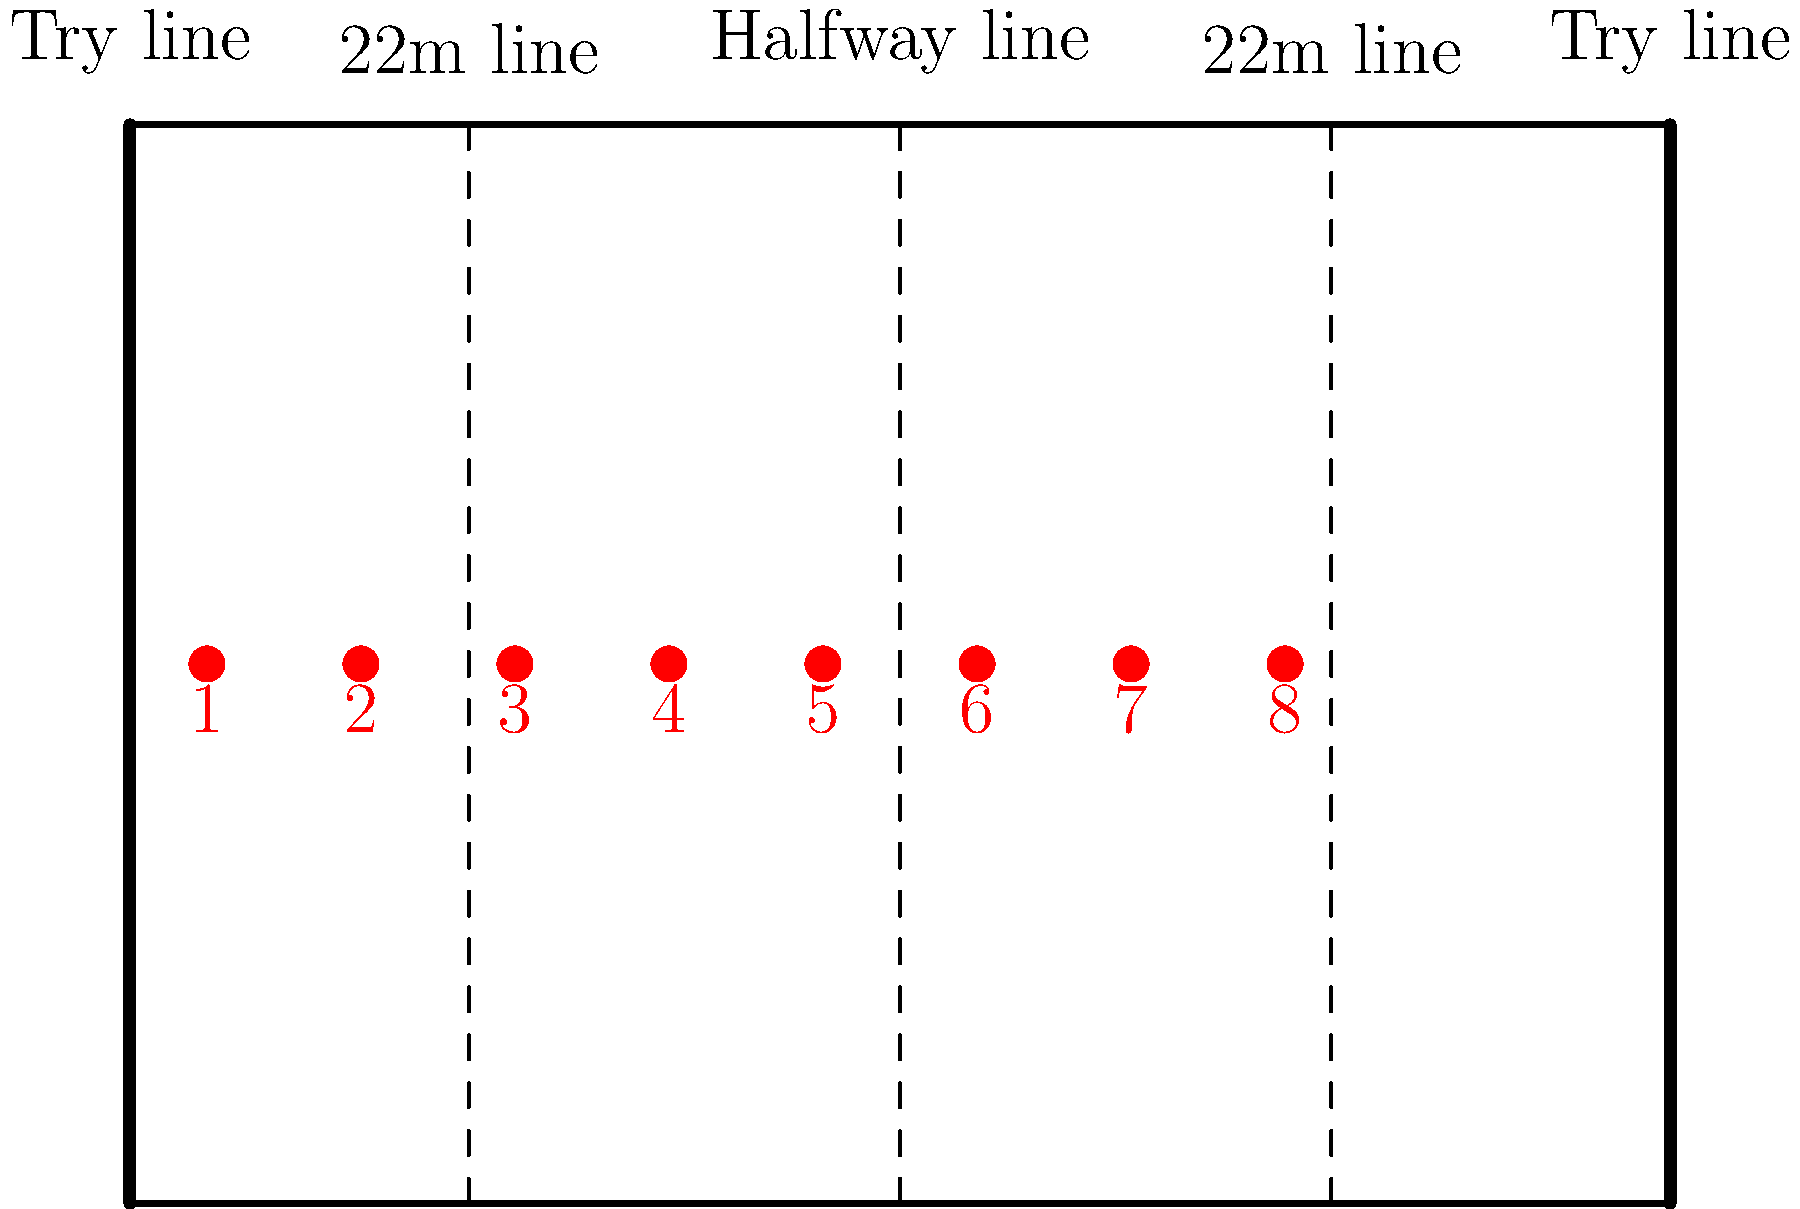In the diagram above, which numbered position represents the player who typically plays as the hooker in a rugby union team? To answer this question, we need to understand the typical positioning of players in a rugby union team:

1. The diagram shows 8 player positions, numbered from 1 to 8.
2. In rugby union, player numbers correspond to specific positions on the field.
3. The hooker is traditionally assigned the number 2 jersey.
4. The hooker plays in the front row of the scrum, between the two props (numbers 1 and 3).
5. Looking at the diagram, we can see that position 2 is the second from the left.

Therefore, the player in position 2 represents the hooker in a rugby union team.
Answer: 2 